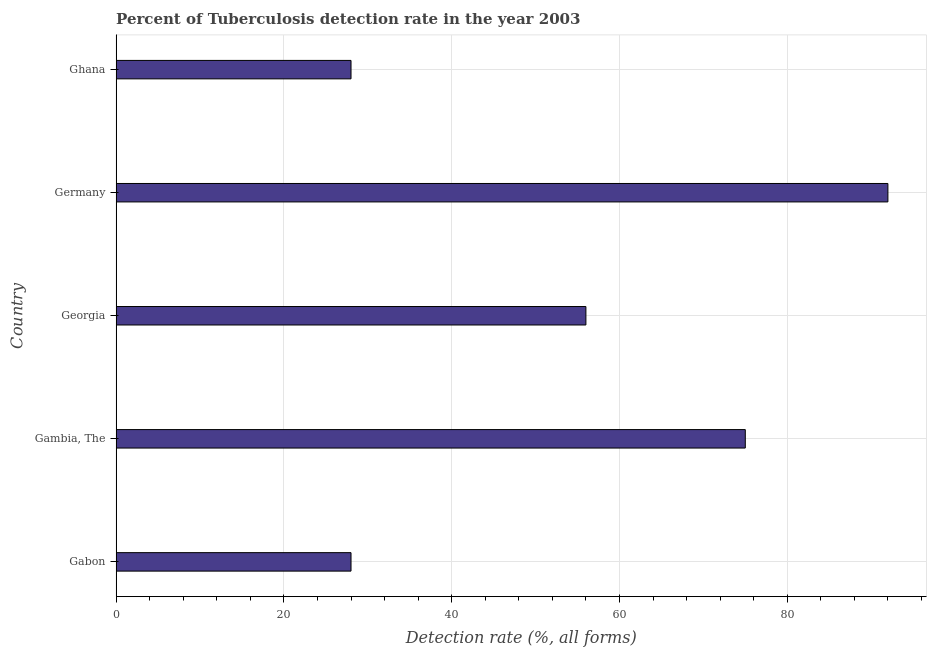What is the title of the graph?
Make the answer very short. Percent of Tuberculosis detection rate in the year 2003. What is the label or title of the X-axis?
Your answer should be very brief. Detection rate (%, all forms). What is the label or title of the Y-axis?
Provide a short and direct response. Country. Across all countries, what is the maximum detection rate of tuberculosis?
Offer a terse response. 92. Across all countries, what is the minimum detection rate of tuberculosis?
Provide a short and direct response. 28. In which country was the detection rate of tuberculosis minimum?
Give a very brief answer. Gabon. What is the sum of the detection rate of tuberculosis?
Your answer should be compact. 279. What is the average detection rate of tuberculosis per country?
Offer a terse response. 55.8. Is the detection rate of tuberculosis in Gambia, The less than that in Ghana?
Provide a succinct answer. No. What is the difference between the highest and the second highest detection rate of tuberculosis?
Your answer should be very brief. 17. Is the sum of the detection rate of tuberculosis in Gambia, The and Ghana greater than the maximum detection rate of tuberculosis across all countries?
Offer a very short reply. Yes. What is the difference between the highest and the lowest detection rate of tuberculosis?
Your response must be concise. 64. Are all the bars in the graph horizontal?
Your answer should be very brief. Yes. What is the Detection rate (%, all forms) of Gabon?
Provide a short and direct response. 28. What is the Detection rate (%, all forms) of Germany?
Provide a succinct answer. 92. What is the difference between the Detection rate (%, all forms) in Gabon and Gambia, The?
Make the answer very short. -47. What is the difference between the Detection rate (%, all forms) in Gabon and Georgia?
Provide a succinct answer. -28. What is the difference between the Detection rate (%, all forms) in Gabon and Germany?
Offer a very short reply. -64. What is the difference between the Detection rate (%, all forms) in Gabon and Ghana?
Make the answer very short. 0. What is the difference between the Detection rate (%, all forms) in Gambia, The and Georgia?
Provide a short and direct response. 19. What is the difference between the Detection rate (%, all forms) in Gambia, The and Ghana?
Provide a short and direct response. 47. What is the difference between the Detection rate (%, all forms) in Georgia and Germany?
Make the answer very short. -36. What is the difference between the Detection rate (%, all forms) in Georgia and Ghana?
Give a very brief answer. 28. What is the difference between the Detection rate (%, all forms) in Germany and Ghana?
Make the answer very short. 64. What is the ratio of the Detection rate (%, all forms) in Gabon to that in Gambia, The?
Your answer should be very brief. 0.37. What is the ratio of the Detection rate (%, all forms) in Gabon to that in Germany?
Ensure brevity in your answer.  0.3. What is the ratio of the Detection rate (%, all forms) in Gabon to that in Ghana?
Offer a very short reply. 1. What is the ratio of the Detection rate (%, all forms) in Gambia, The to that in Georgia?
Keep it short and to the point. 1.34. What is the ratio of the Detection rate (%, all forms) in Gambia, The to that in Germany?
Offer a terse response. 0.81. What is the ratio of the Detection rate (%, all forms) in Gambia, The to that in Ghana?
Give a very brief answer. 2.68. What is the ratio of the Detection rate (%, all forms) in Georgia to that in Germany?
Your response must be concise. 0.61. What is the ratio of the Detection rate (%, all forms) in Georgia to that in Ghana?
Your response must be concise. 2. What is the ratio of the Detection rate (%, all forms) in Germany to that in Ghana?
Offer a very short reply. 3.29. 